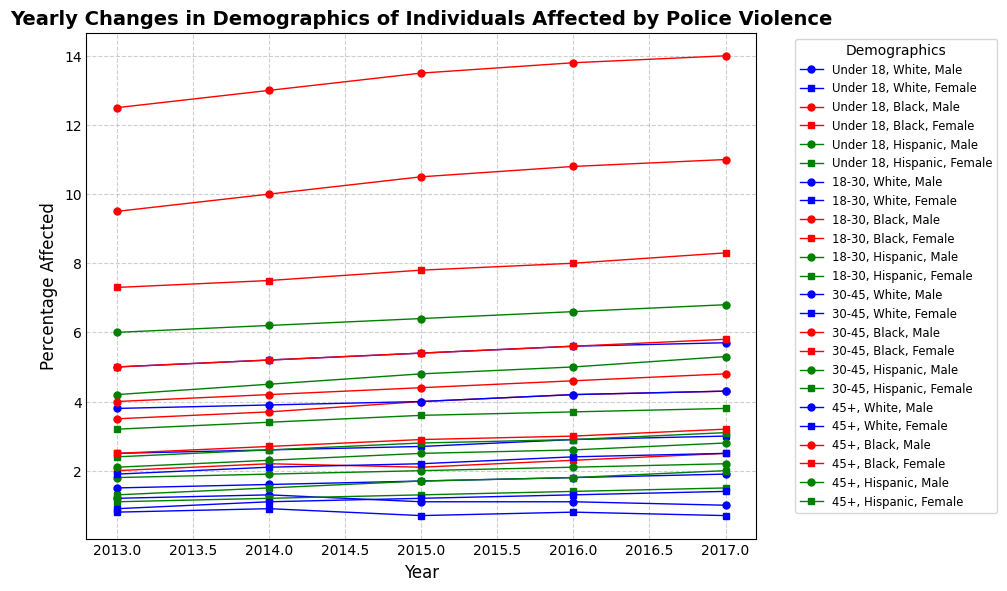What percentage of 18-30 Black males were affected by police violence in 2017? Locate the line corresponding to 18-30 Black males, noting the marker color (red) and shape (circle). Find the point for the year 2017 and read the percentage value.
Answer: 14.0 Which group had the highest percentage of individuals affected by police violence in 2016? Compare the peak points of all lines for the year 2016. Identify the highest point and the corresponding demographic group.
Answer: 18-30 Black males Did the percentage of under-18 Black females affected by police violence increase or decrease from 2013 to 2017? Trace the line for under-18 Black females indicated by the red color and square marker from 2013 to 2017, noting whether the line trends upward or downward.
Answer: Increase What is the difference in the percentage of 30-45 Hispanic males and 30-45 Hispanic females affected by police violence in 2015? Locate the lines for 30-45 Hispanic males (green, circle marker) and 30-45 Hispanic females (green, square marker) for 2015. Subtract the percentage of females from males.
Answer: 2.0 Which gender had a higher percentage of individuals affected by police violence in the 18-30 age group for the year 2014? For the year 2014, compare the lines representing males and females for the 18-30 age group across all races. Mainly look at the markers to see which gender had higher points.
Answer: Male Was the percentage of affected individuals higher for under-18 Hispanic males or under-18 Hispanic females in 2016? Compare the points for under-18 Hispanic males (green, circle) and under-18 Hispanic females (green, square) for the year 2016.
Answer: Males How did the percentage of 45+ White females change from 2014 to 2017? Follow the line for 45+ White females (blue, square) from 2014 to 2017, noting if the line trends upward, downward, or stays flat.
Answer: Increase Which age group saw the highest increase in the percentage of Black males affected by police violence between 2013 and 2017? Examine the lines for Black males across different age groups from 2013 to 2017. Calculate the percentage change for each age group (2017 value - 2013 value) to find the highest increase.
Answer: Under 18 Between 2013 and 2015, did the percentage of 18-30 Hispanic females increase, decrease, or remain constant? Analyze the line for 18-30 Hispanic females (green, square) from 2013 to 2015, noting whether it trends upward, downward, or remains horizontal.
Answer: Increase What is the average percentage of 30-45 White males affected by police violence from 2013 to 2017? Find the line for 30-45 White males (blue, circle) and read the values for each year from 2013 to 2017. Calculate the average by summing the values and dividing by the number of years.
Answer: 4.04 Which demographic had the lowest percentage affected by police violence in 2015 among all groups? Identify the lowest point on the graph for the year 2015 and determine the corresponding demographic group.
Answer: Under-18 White females 